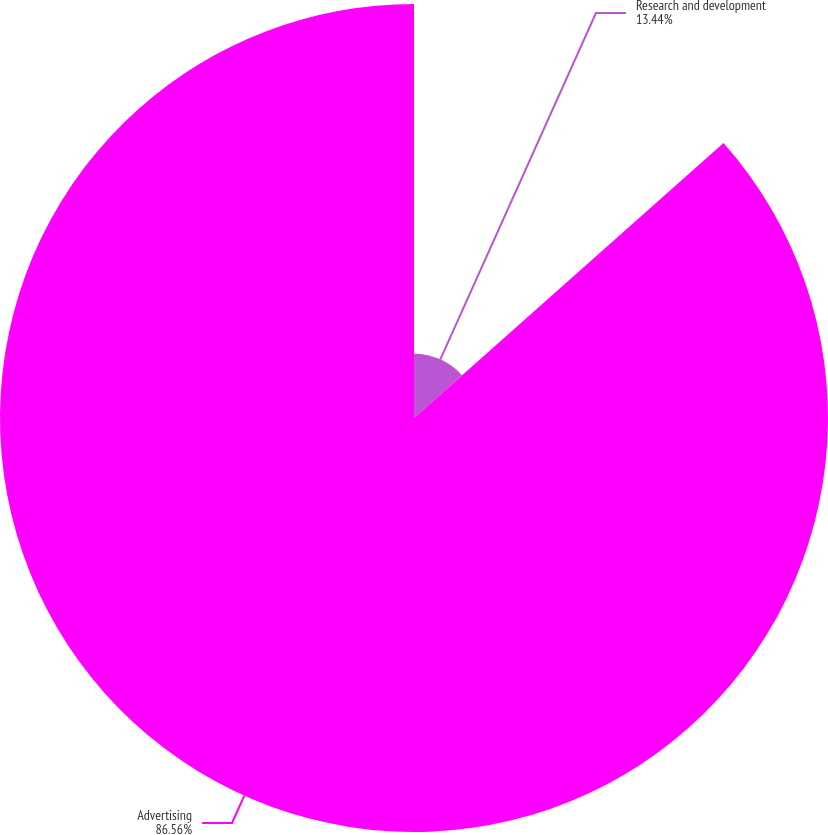Convert chart. <chart><loc_0><loc_0><loc_500><loc_500><pie_chart><fcel>Research and development<fcel>Advertising<nl><fcel>13.44%<fcel>86.56%<nl></chart> 